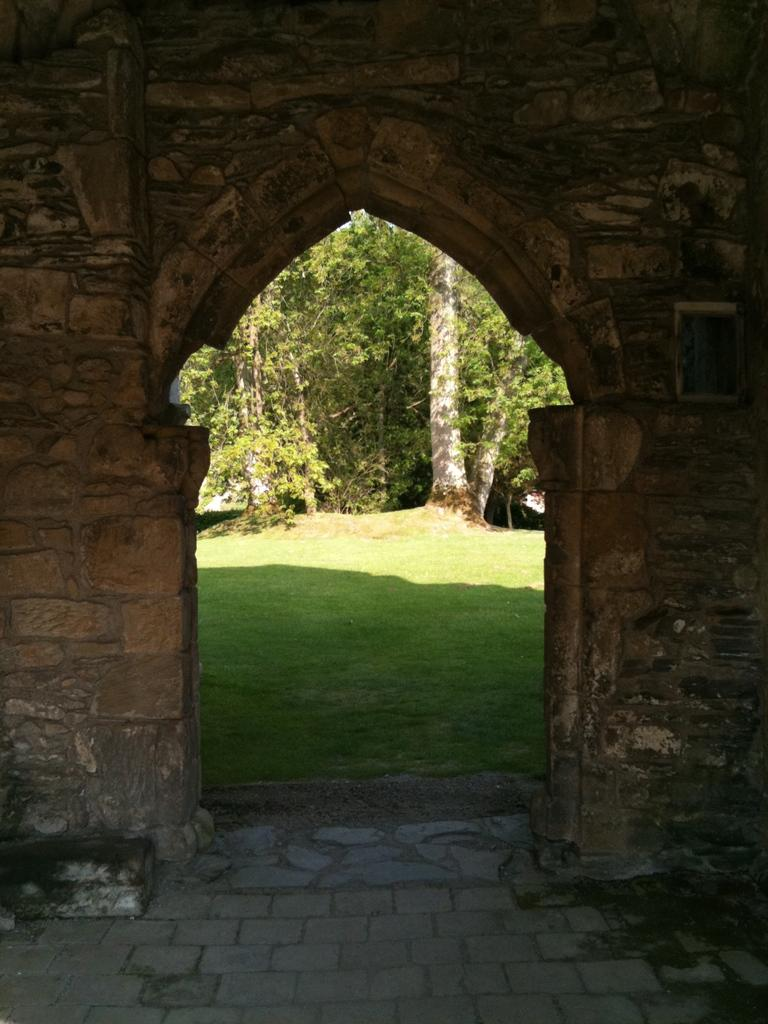What type of structure is present in the image? There is an arch in the image. What else can be seen in the image besides the arch? There is a building wall, grass, trees with branches and leaves, and a floor visible at the bottom of the image. How many cherries are hanging from the branches of the trees in the image? There are no cherries present in the image; the trees have branches and leaves. What type of weather condition is depicted in the image, indicated by the presence of thunder? There is no mention of thunder or any weather condition in the image; it simply shows an arch, a building wall, grass, trees, and a floor. 